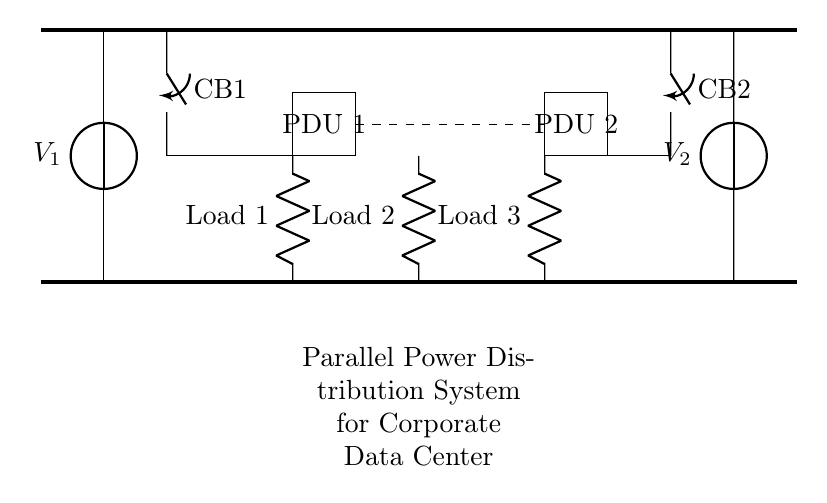What are the two main power sources? The circuit diagram identifies two voltage sources, labeled as V1 and V2, indicating they are the main power sources for the distribution system.
Answer: V1 and V2 How many circuit breakers are shown? The diagram shows two circuit breakers, labeled as CB1 and CB2, which are connected to each of the voltage sources. This can be counted directly from the circuit.
Answer: 2 What is the function of the dashed line in the diagram? The dashed line indicates redundant connections between the Power Distribution Units (PDUs). It represents an alternative pathway for power to maintain system reliability, highlighting the redundancy in the setup.
Answer: Redundancy Which components are labeled as loads? The components labeled as loads are shown as resistors in the diagram—specifically, Load 1, Load 2, and Load 3. Identifying these components involves looking for the resistors connected to the lower bus, indicated by their labels.
Answer: Load 1, Load 2, Load 3 What type of circuit is represented? The diagram represents a parallel power distribution system, as can be inferred from the multiple paths for current provided by the parallel arrangement of the PDUs and loads, allowing for redundancy and reliability.
Answer: Parallel Which component connects directly to both PDUs? The components connected to both PDUs are the circuit breakers CB1 and CB2, which serve as the interface between the power sources and the PDUs. This can be observed from the lines connecting them directly to the PDUs.
Answer: Circuit breakers 